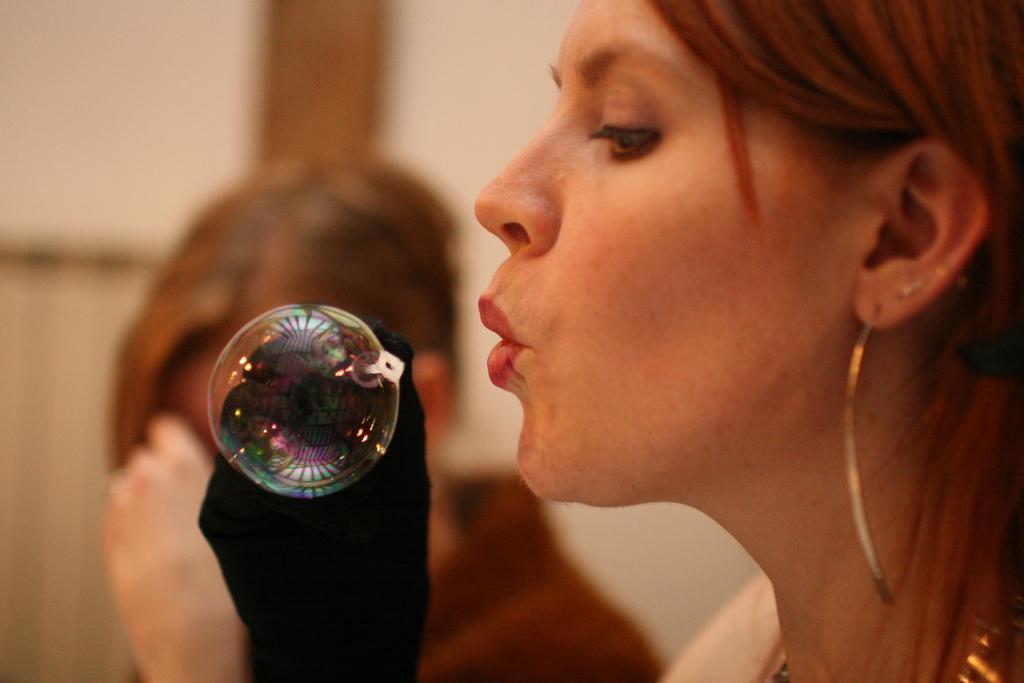In one or two sentences, can you explain what this image depicts? On the right there is a woman who is wearing earring and gloves. She is holding plastic stick. Here we can see another woman who is wearing brown dress. She is standing near to the door. 